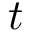Convert formula to latex. <formula><loc_0><loc_0><loc_500><loc_500>t</formula> 